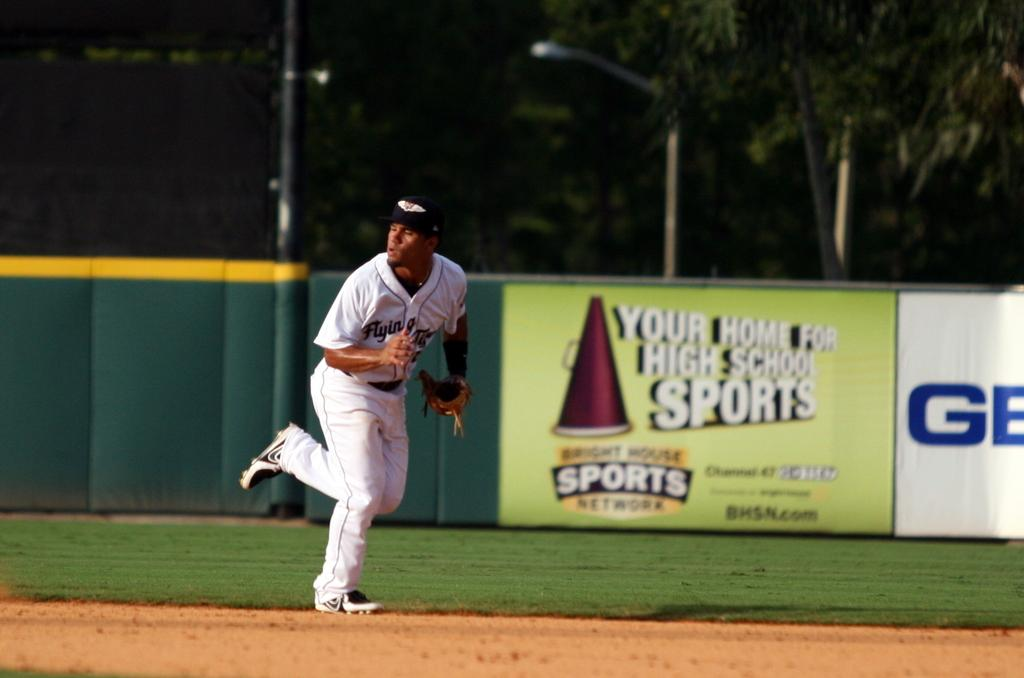<image>
Relay a brief, clear account of the picture shown. A player in a white uniform runs in front of a sign with BHSN.com. 